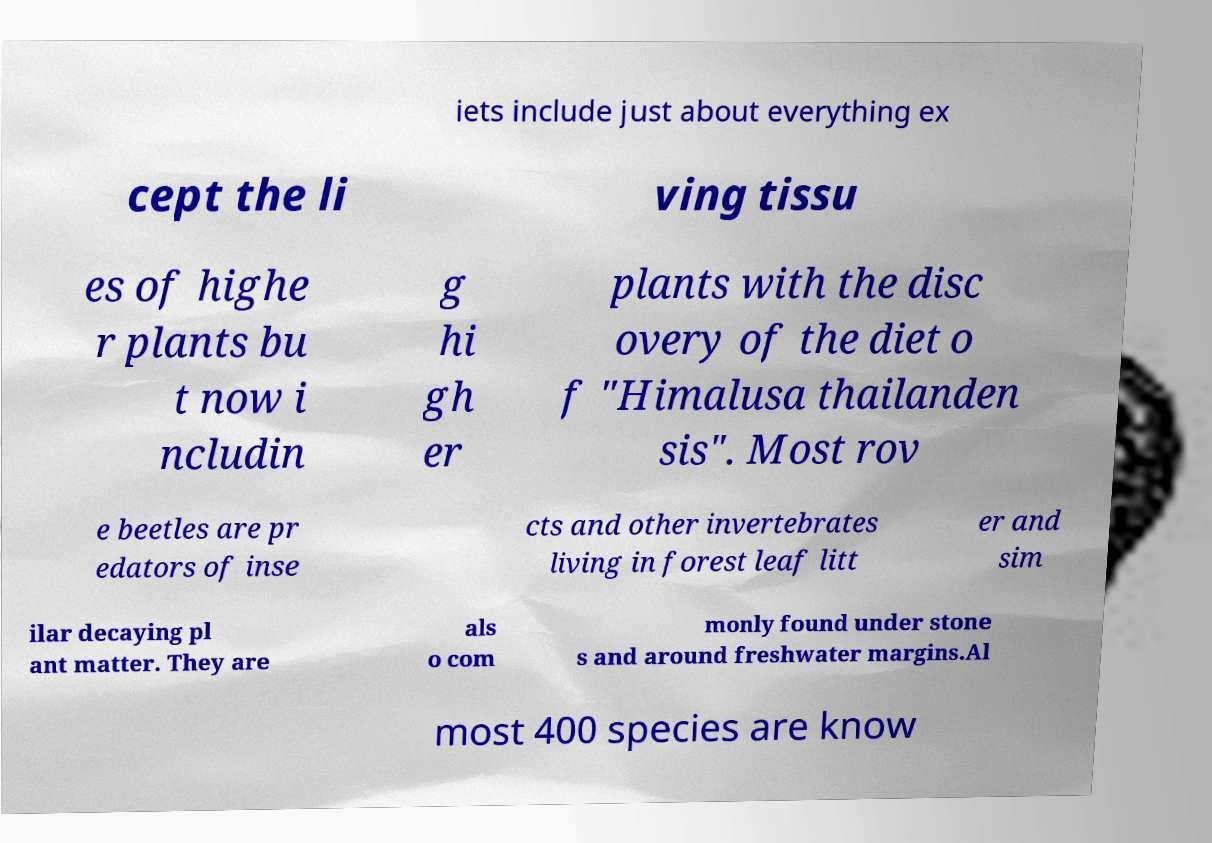Please read and relay the text visible in this image. What does it say? iets include just about everything ex cept the li ving tissu es of highe r plants bu t now i ncludin g hi gh er plants with the disc overy of the diet o f "Himalusa thailanden sis". Most rov e beetles are pr edators of inse cts and other invertebrates living in forest leaf litt er and sim ilar decaying pl ant matter. They are als o com monly found under stone s and around freshwater margins.Al most 400 species are know 